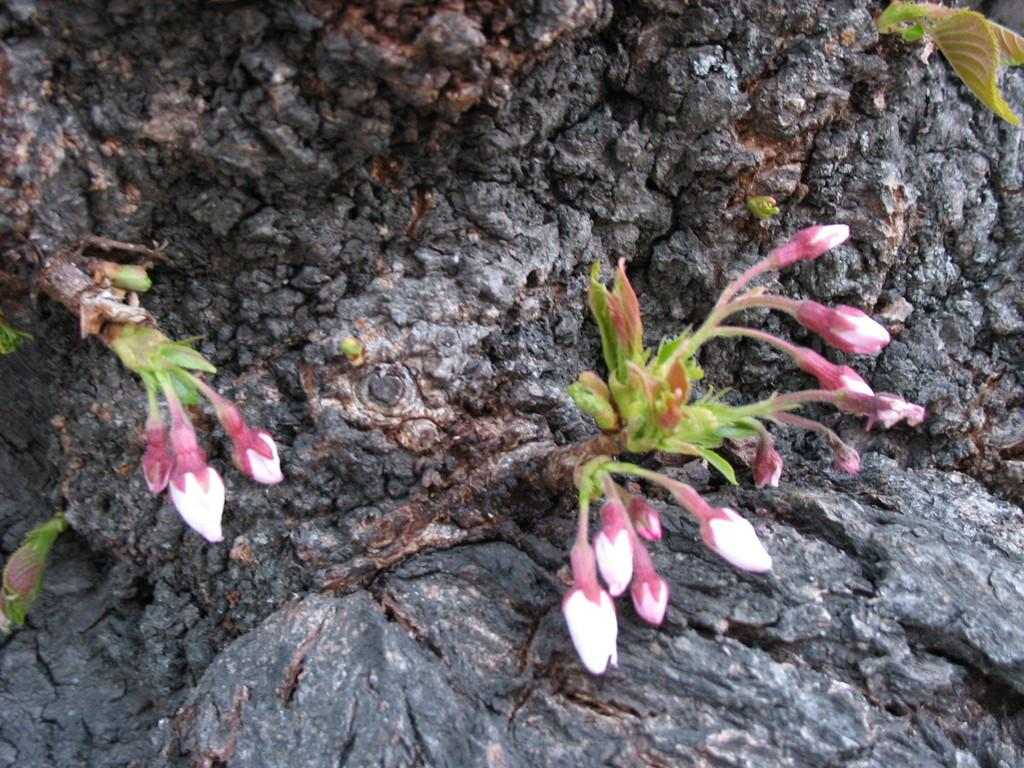What type of plant life can be seen in the image? There are buds and green leaves in the image. Can you describe the stage of growth of the plant life? The presence of buds suggests that the plants are in the early stages of growth. What type of soup is being served in the image? There is no soup present in the image; it features buds and green leaves. How many bears can be seen interacting with the plants in the image? There are no bears present in the image; it only features plant life. 